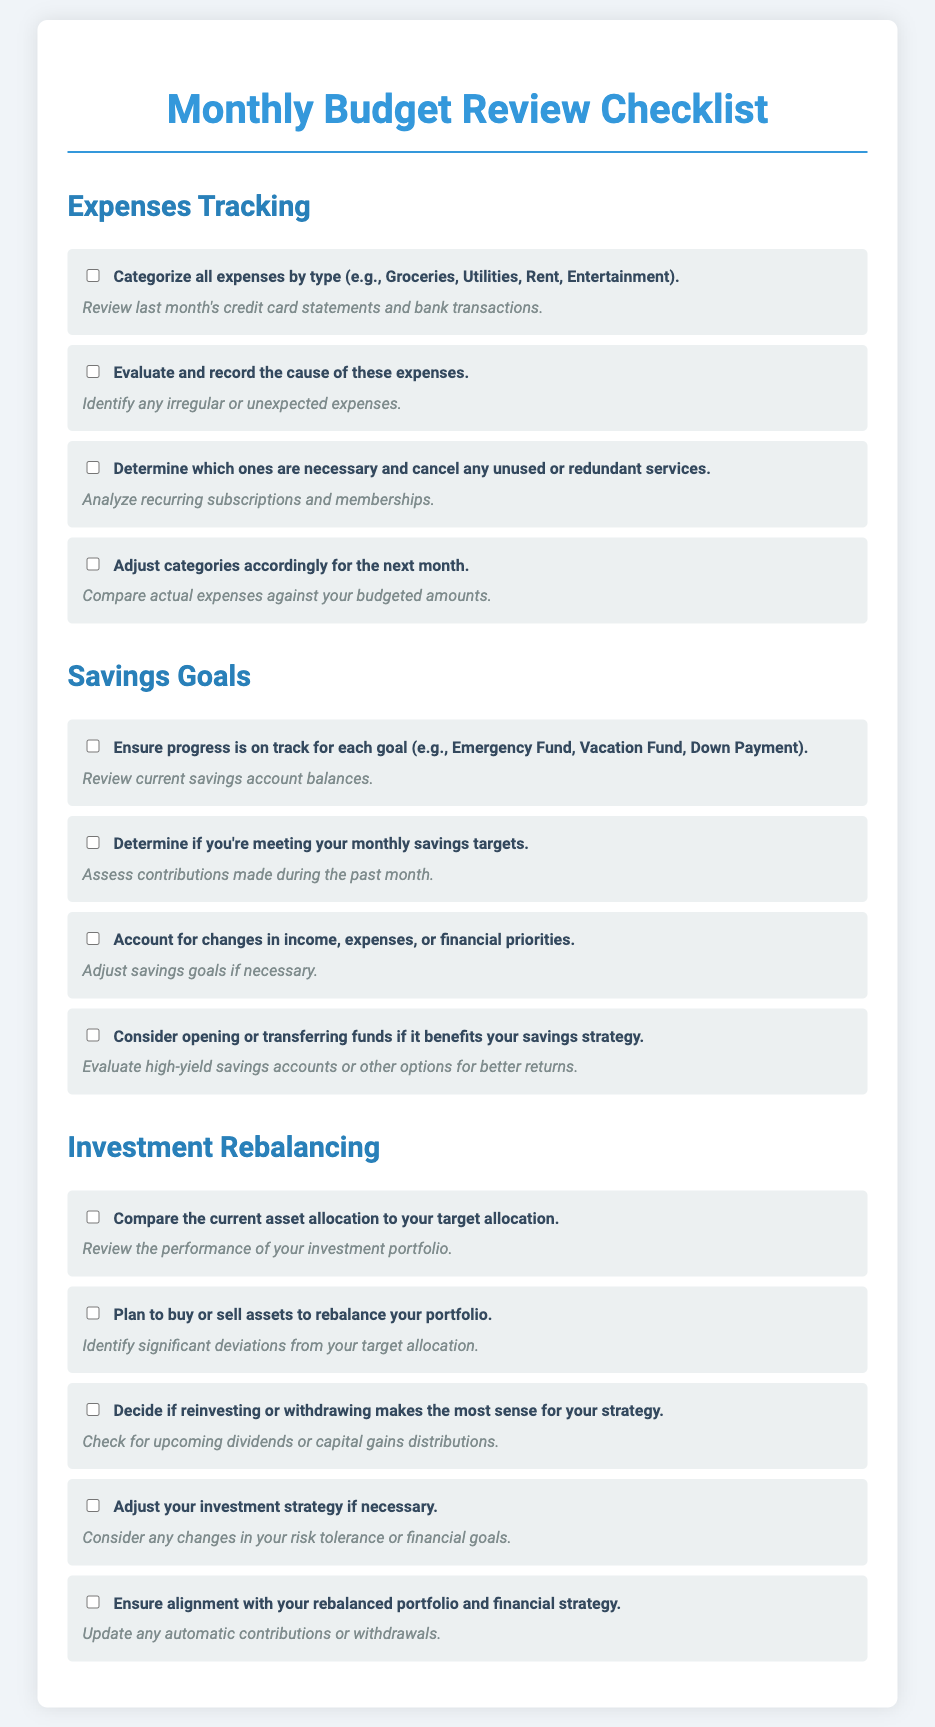What are the categories for expense tracking? The categories for expense tracking include Groceries, Utilities, Rent, and Entertainment.
Answer: Groceries, Utilities, Rent, Entertainment How many tasks are listed under Savings Goals? There are four tasks listed under Savings Goals in the checklist.
Answer: 4 What should you assess regarding contributions in the Savings Goals section? You should assess contributions made during the past month.
Answer: Contributions made during the past month What action should be taken about unused services in Expenses Tracking? You should determine which ones are necessary and cancel any unused or redundant services.
Answer: Cancel any unused or redundant services What is the objective of comparing current asset allocation in Investment Rebalancing? The objective is to compare the current asset allocation to your target allocation.
Answer: Compare to your target allocation How many tasks are outlined in the Investment Rebalancing section? There are five tasks outlined in the Investment Rebalancing section.
Answer: 5 What type of accounts could be evaluated for better returns in Savings Goals? High-yield savings accounts can be evaluated for better returns.
Answer: High-yield savings accounts What should be reviewed to ensure progress in Savings Goals? Current savings account balances should be reviewed to ensure progress.
Answer: Current savings account balances What should be adjusted if financial priorities change? Savings goals should be adjusted if necessary.
Answer: Savings goals 